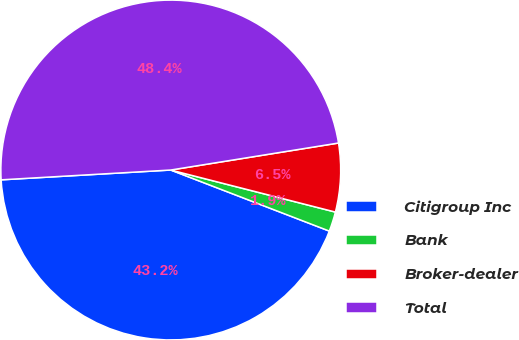Convert chart. <chart><loc_0><loc_0><loc_500><loc_500><pie_chart><fcel>Citigroup Inc<fcel>Bank<fcel>Broker-dealer<fcel>Total<nl><fcel>43.23%<fcel>1.87%<fcel>6.52%<fcel>48.38%<nl></chart> 